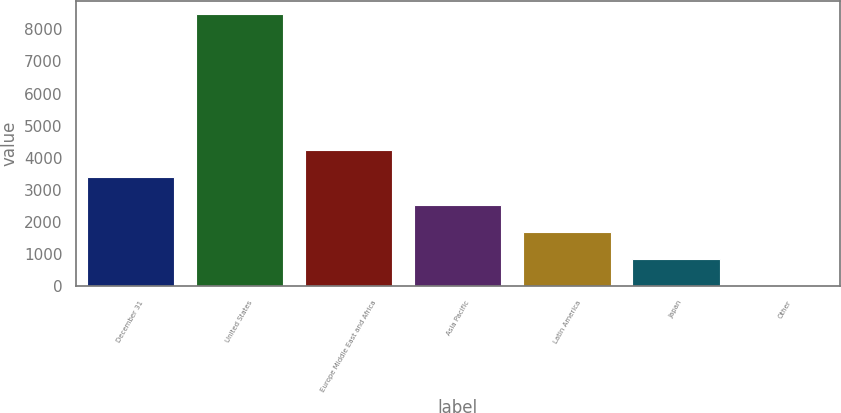Convert chart. <chart><loc_0><loc_0><loc_500><loc_500><bar_chart><fcel>December 31<fcel>United States<fcel>Europe Middle East and Africa<fcel>Asia Pacific<fcel>Latin America<fcel>Japan<fcel>Other<nl><fcel>3391.6<fcel>8467<fcel>4237.5<fcel>2545.7<fcel>1699.8<fcel>853.9<fcel>8<nl></chart> 